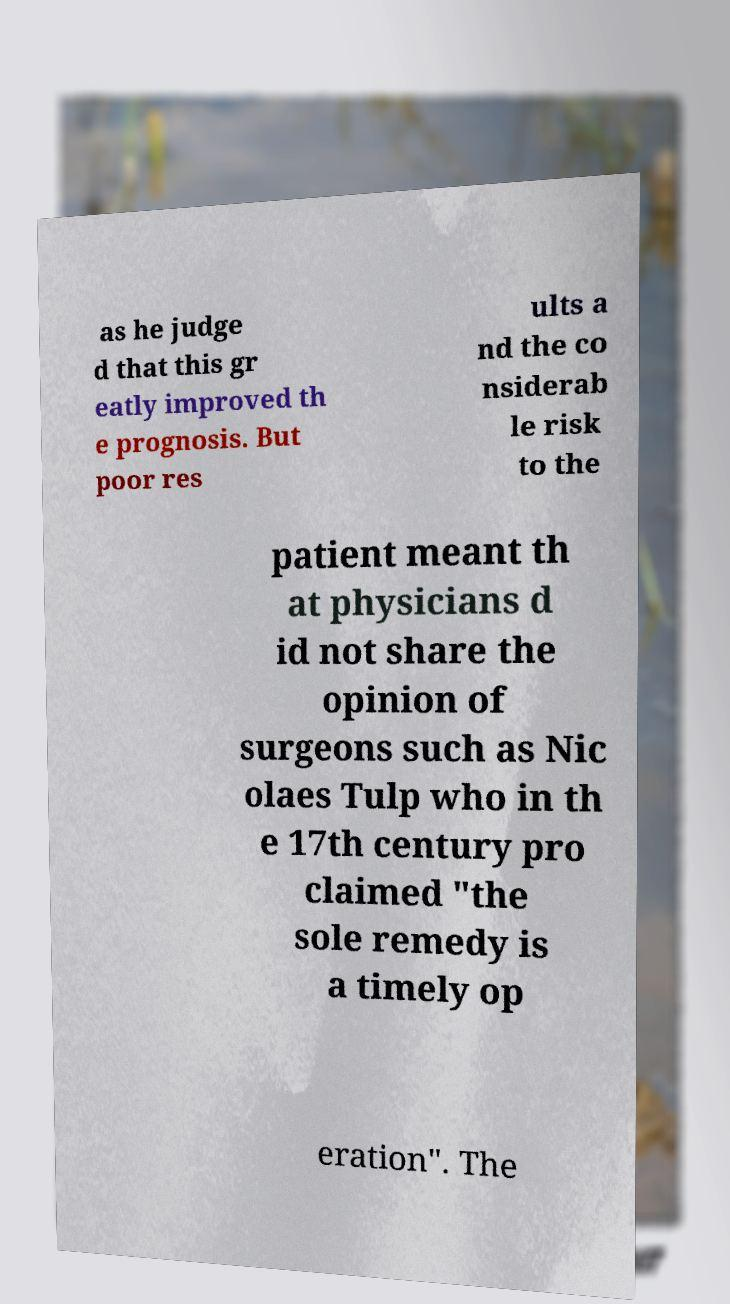Could you extract and type out the text from this image? as he judge d that this gr eatly improved th e prognosis. But poor res ults a nd the co nsiderab le risk to the patient meant th at physicians d id not share the opinion of surgeons such as Nic olaes Tulp who in th e 17th century pro claimed "the sole remedy is a timely op eration". The 